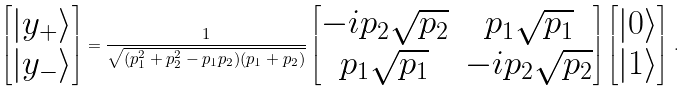<formula> <loc_0><loc_0><loc_500><loc_500>\begin{bmatrix} | y _ { + } \rangle \\ | y _ { - } \rangle \end{bmatrix} = \frac { 1 } { \sqrt { ( p _ { 1 } ^ { 2 } + p _ { 2 } ^ { 2 } - p _ { 1 } p _ { 2 } ) ( p _ { 1 } + p _ { 2 } ) } } \begin{bmatrix} - i p _ { 2 } \sqrt { p _ { 2 } } & p _ { 1 } \sqrt { p _ { 1 } } \\ p _ { 1 } \sqrt { p _ { 1 } } & - i p _ { 2 } \sqrt { p _ { 2 } } \end{bmatrix} \begin{bmatrix} | 0 \rangle \\ | 1 \rangle \end{bmatrix} \, .</formula> 